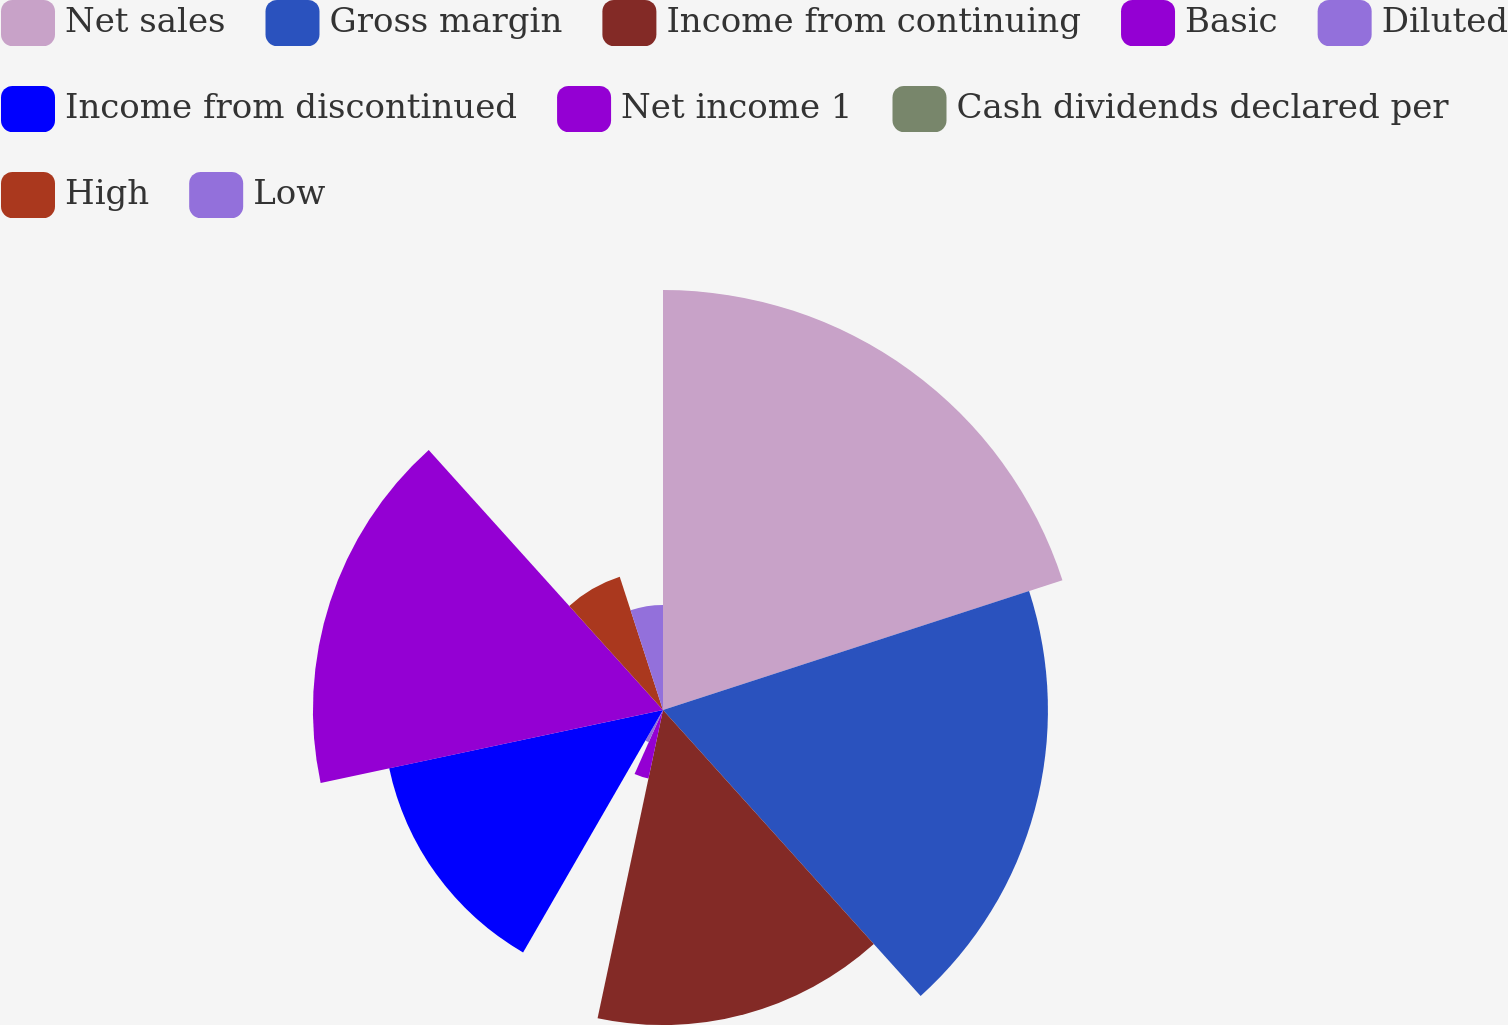Convert chart to OTSL. <chart><loc_0><loc_0><loc_500><loc_500><pie_chart><fcel>Net sales<fcel>Gross margin<fcel>Income from continuing<fcel>Basic<fcel>Diluted<fcel>Income from discontinued<fcel>Net income 1<fcel>Cash dividends declared per<fcel>High<fcel>Low<nl><fcel>20.0%<fcel>18.33%<fcel>15.0%<fcel>3.33%<fcel>1.67%<fcel>13.33%<fcel>16.67%<fcel>0.0%<fcel>6.67%<fcel>5.0%<nl></chart> 